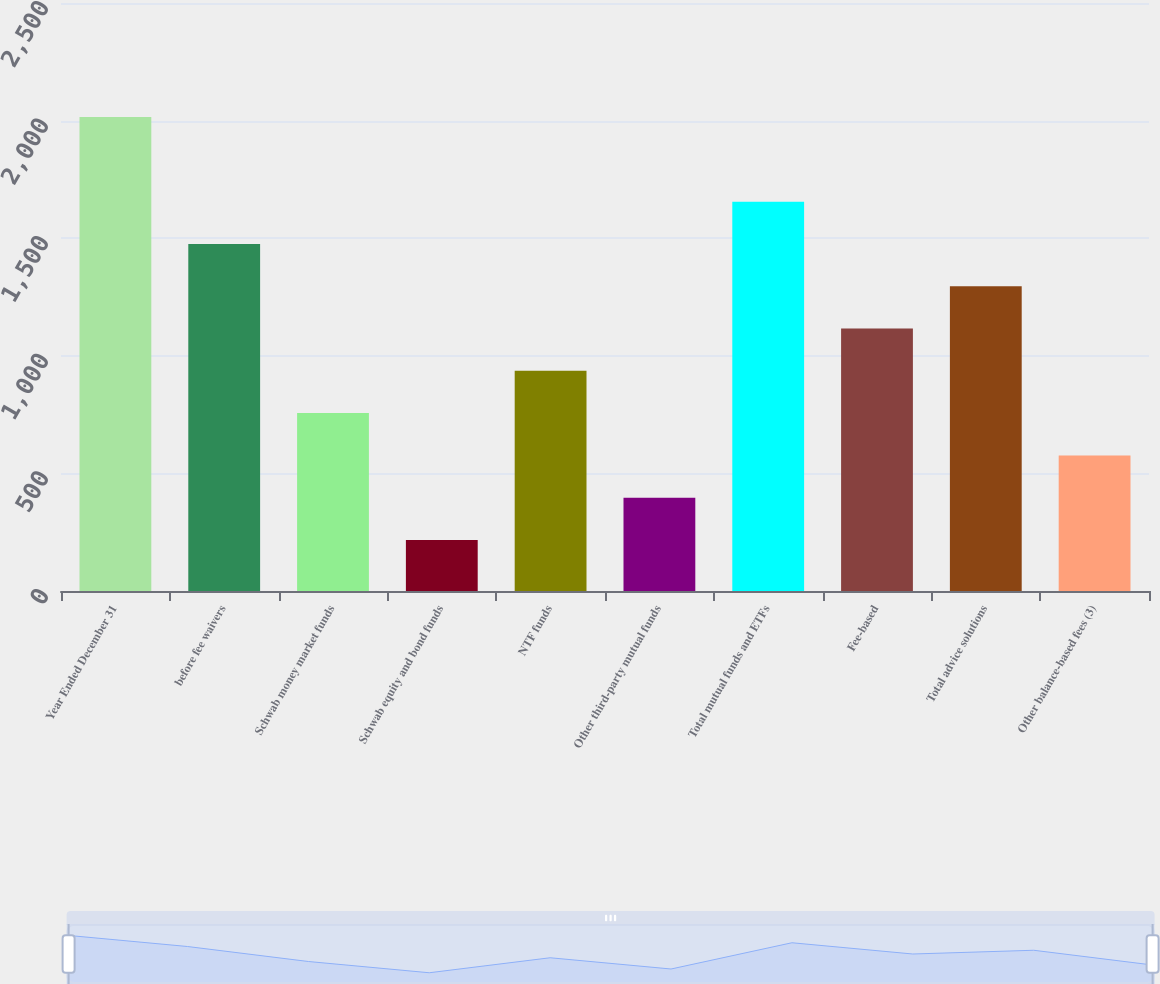Convert chart to OTSL. <chart><loc_0><loc_0><loc_500><loc_500><bar_chart><fcel>Year Ended December 31<fcel>before fee waivers<fcel>Schwab money market funds<fcel>Schwab equity and bond funds<fcel>NTF funds<fcel>Other third-party mutual funds<fcel>Total mutual funds and ETFs<fcel>Fee-based<fcel>Total advice solutions<fcel>Other balance-based fees (3)<nl><fcel>2015<fcel>1475.6<fcel>756.4<fcel>217<fcel>936.2<fcel>396.8<fcel>1655.4<fcel>1116<fcel>1295.8<fcel>576.6<nl></chart> 